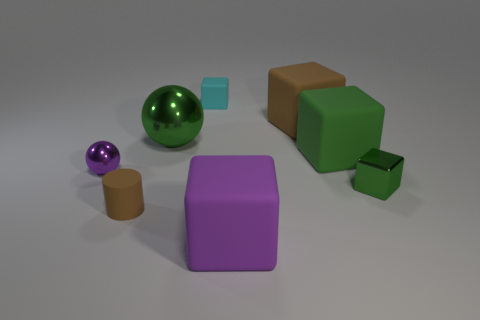Subtract all yellow blocks. Subtract all purple balls. How many blocks are left? 5 Add 1 small cyan things. How many objects exist? 9 Subtract all balls. How many objects are left? 6 Add 3 big green matte things. How many big green matte things are left? 4 Add 1 large cubes. How many large cubes exist? 4 Subtract 0 blue cylinders. How many objects are left? 8 Subtract all purple metal cylinders. Subtract all large green rubber things. How many objects are left? 7 